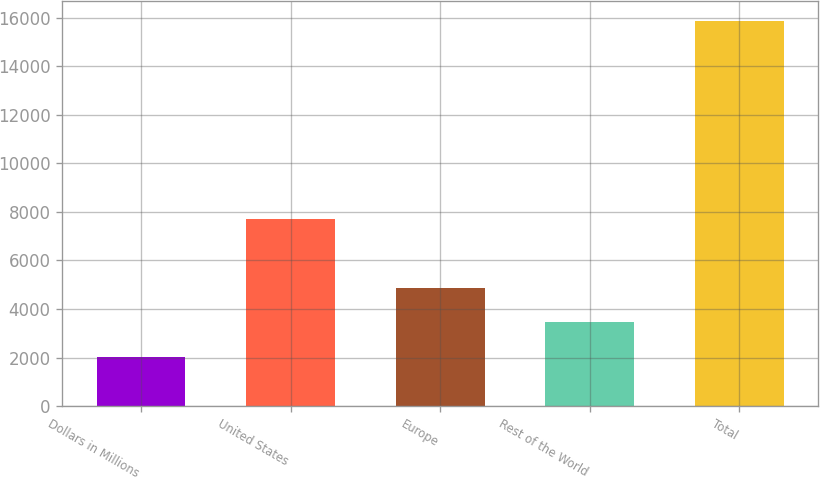Convert chart. <chart><loc_0><loc_0><loc_500><loc_500><bar_chart><fcel>Dollars in Millions<fcel>United States<fcel>Europe<fcel>Rest of the World<fcel>Total<nl><fcel>2014<fcel>7716<fcel>4845.5<fcel>3459<fcel>15879<nl></chart> 